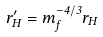Convert formula to latex. <formula><loc_0><loc_0><loc_500><loc_500>r _ { H } ^ { \prime } = m _ { f } ^ { - 4 / 3 } { r _ { H } }</formula> 